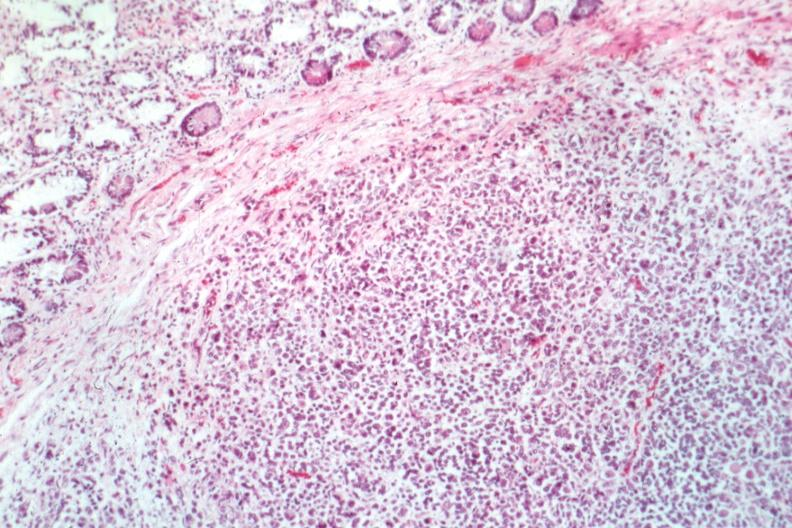s small intestine present?
Answer the question using a single word or phrase. Yes 